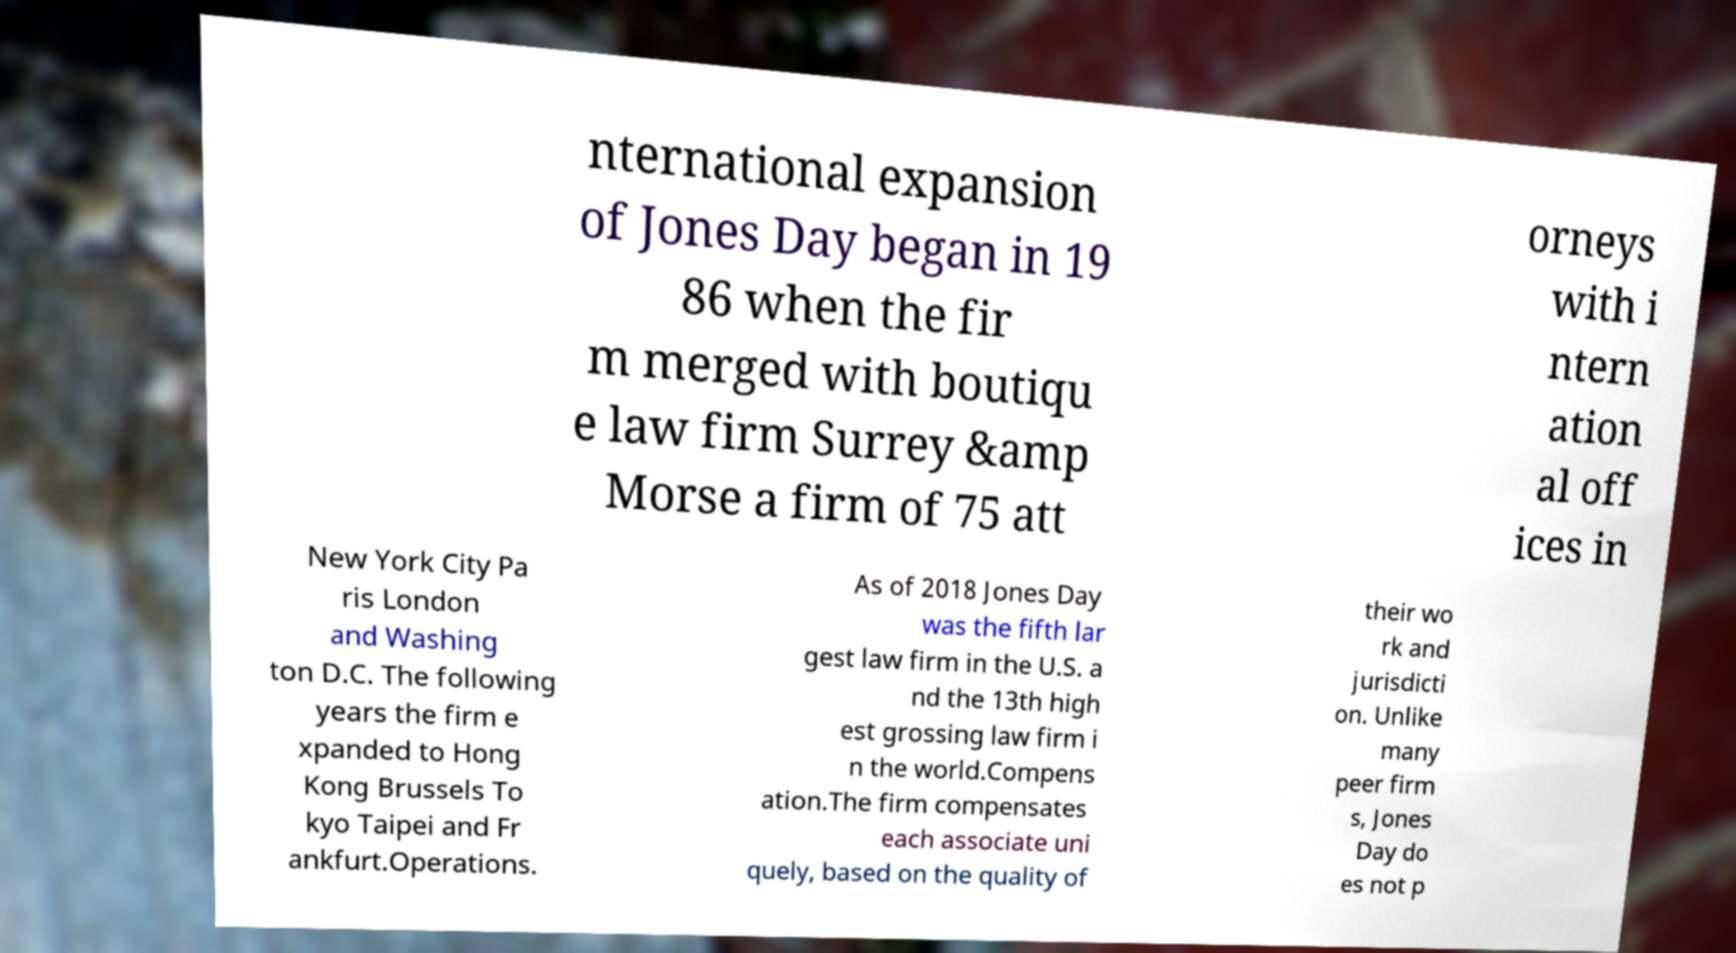Can you accurately transcribe the text from the provided image for me? nternational expansion of Jones Day began in 19 86 when the fir m merged with boutiqu e law firm Surrey &amp Morse a firm of 75 att orneys with i ntern ation al off ices in New York City Pa ris London and Washing ton D.C. The following years the firm e xpanded to Hong Kong Brussels To kyo Taipei and Fr ankfurt.Operations. As of 2018 Jones Day was the fifth lar gest law firm in the U.S. a nd the 13th high est grossing law firm i n the world.Compens ation.The firm compensates each associate uni quely, based on the quality of their wo rk and jurisdicti on. Unlike many peer firm s, Jones Day do es not p 